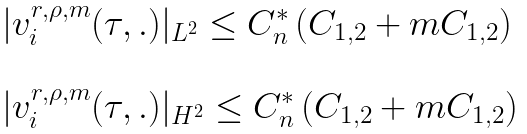<formula> <loc_0><loc_0><loc_500><loc_500>\begin{array} { l l } | v ^ { r , \rho , m } _ { i } ( \tau , . ) | _ { L ^ { 2 } } \leq C ^ { * } _ { n } \left ( C _ { 1 , 2 } + m C _ { 1 , 2 } \right ) \\ \\ | v ^ { r , \rho , m } _ { i } ( \tau , . ) | _ { H ^ { 2 } } \leq C ^ { * } _ { n } \left ( C _ { 1 , 2 } + m C _ { 1 , 2 } \right ) \end{array}</formula> 